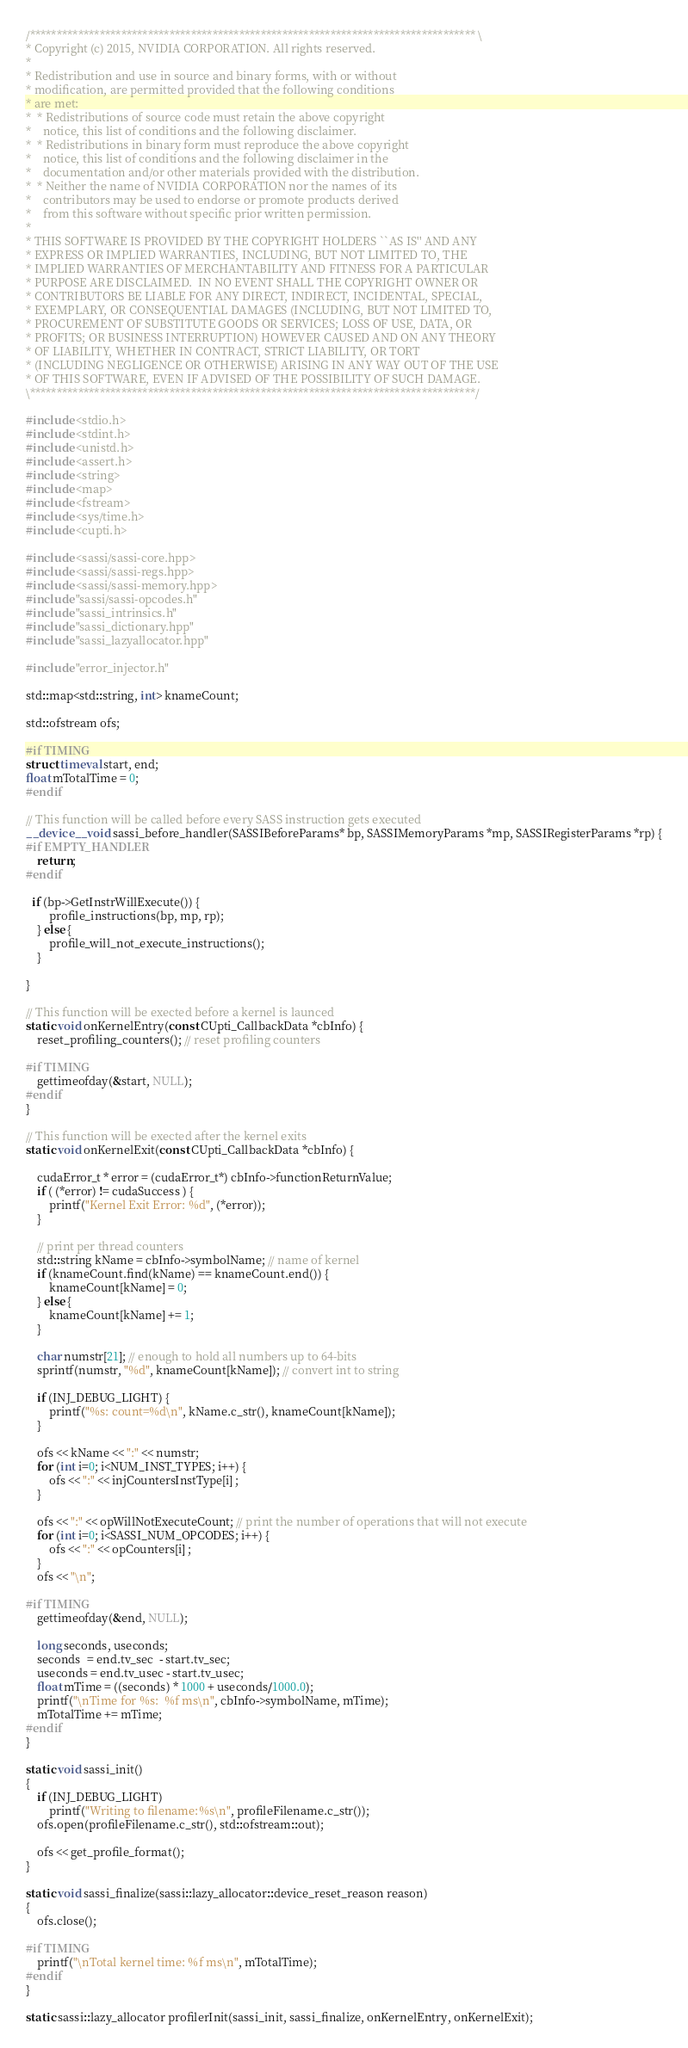<code> <loc_0><loc_0><loc_500><loc_500><_Cuda_>/*********************************************************************************** \
* Copyright (c) 2015, NVIDIA CORPORATION. All rights reserved.
*
* Redistribution and use in source and binary forms, with or without
* modification, are permitted provided that the following conditions
* are met:
*  * Redistributions of source code must retain the above copyright
*    notice, this list of conditions and the following disclaimer.
*  * Redistributions in binary form must reproduce the above copyright
*    notice, this list of conditions and the following disclaimer in the
*    documentation and/or other materials provided with the distribution.
*  * Neither the name of NVIDIA CORPORATION nor the names of its
*    contributors may be used to endorse or promote products derived
*    from this software without specific prior written permission.
*
* THIS SOFTWARE IS PROVIDED BY THE COPYRIGHT HOLDERS ``AS IS'' AND ANY
* EXPRESS OR IMPLIED WARRANTIES, INCLUDING, BUT NOT LIMITED TO, THE
* IMPLIED WARRANTIES OF MERCHANTABILITY AND FITNESS FOR A PARTICULAR
* PURPOSE ARE DISCLAIMED.  IN NO EVENT SHALL THE COPYRIGHT OWNER OR
* CONTRIBUTORS BE LIABLE FOR ANY DIRECT, INDIRECT, INCIDENTAL, SPECIAL,
* EXEMPLARY, OR CONSEQUENTIAL DAMAGES (INCLUDING, BUT NOT LIMITED TO,
* PROCUREMENT OF SUBSTITUTE GOODS OR SERVICES; LOSS OF USE, DATA, OR
* PROFITS; OR BUSINESS INTERRUPTION) HOWEVER CAUSED AND ON ANY THEORY
* OF LIABILITY, WHETHER IN CONTRACT, STRICT LIABILITY, OR TORT
* (INCLUDING NEGLIGENCE OR OTHERWISE) ARISING IN ANY WAY OUT OF THE USE
* OF THIS SOFTWARE, EVEN IF ADVISED OF THE POSSIBILITY OF SUCH DAMAGE.
\***********************************************************************************/

#include <stdio.h>
#include <stdint.h>
#include <unistd.h>
#include <assert.h>
#include <string>
#include <map>
#include <fstream>
#include <sys/time.h>
#include <cupti.h>

#include <sassi/sassi-core.hpp>
#include <sassi/sassi-regs.hpp>
#include <sassi/sassi-memory.hpp>
#include "sassi/sassi-opcodes.h"
#include "sassi_intrinsics.h"
#include "sassi_dictionary.hpp"
#include "sassi_lazyallocator.hpp"

#include "error_injector.h"

std::map<std::string, int> knameCount;

std::ofstream ofs; 

#if TIMING
struct timeval start, end;
float mTotalTime = 0;
#endif

// This function will be called before every SASS instruction gets executed 
__device__ void sassi_before_handler(SASSIBeforeParams* bp, SASSIMemoryParams *mp, SASSIRegisterParams *rp) {
#if EMPTY_HANDLER
	return;
#endif

  if (bp->GetInstrWillExecute()) {
		profile_instructions(bp, mp, rp);
	} else {
		profile_will_not_execute_instructions();
	}

}

// This function will be exected before a kernel is launced
static void onKernelEntry(const CUpti_CallbackData *cbInfo) {
	reset_profiling_counters(); // reset profiling counters

#if TIMING 
	gettimeofday(&start, NULL);
#endif
} 

// This function will be exected after the kernel exits 
static void onKernelExit(const CUpti_CallbackData *cbInfo) {

	cudaError_t * error = (cudaError_t*) cbInfo->functionReturnValue; 
	if ( (*error) != cudaSuccess ) {
		printf("Kernel Exit Error: %d", (*error));
	}

	// print per thread counters
	std::string kName = cbInfo->symbolName; // name of kernel
	if (knameCount.find(kName) == knameCount.end()) {
		knameCount[kName] = 0;
	} else {
		knameCount[kName] += 1;				
	}

	char numstr[21]; // enough to hold all numbers up to 64-bits
	sprintf(numstr, "%d", knameCount[kName]); // convert int to string

	if (INJ_DEBUG_LIGHT) {
		printf("%s: count=%d\n", kName.c_str(), knameCount[kName]);
	}

	ofs << kName << ":" << numstr;
	for (int i=0; i<NUM_INST_TYPES; i++) {
		ofs << ":" << injCountersInstType[i] ;
	}

	ofs << ":" << opWillNotExecuteCount; // print the number of operations that will not execute
	for (int i=0; i<SASSI_NUM_OPCODES; i++) {
		ofs << ":" << opCounters[i] ;
	}
	ofs << "\n";

#if TIMING
	gettimeofday(&end, NULL);

	long seconds, useconds;    
	seconds  = end.tv_sec  - start.tv_sec;
	useconds = end.tv_usec - start.tv_usec;
	float mTime = ((seconds) * 1000 + useconds/1000.0);
	printf("\nTime for %s:  %f ms\n", cbInfo->symbolName, mTime);
	mTotalTime += mTime;
#endif
} 

static void sassi_init() 
{
	if (INJ_DEBUG_LIGHT)
		printf("Writing to filename:%s\n", profileFilename.c_str());
	ofs.open(profileFilename.c_str(), std::ofstream::out);

	ofs << get_profile_format();
}

static void sassi_finalize(sassi::lazy_allocator::device_reset_reason reason)
{
	ofs.close();

#if TIMING
	printf("\nTotal kernel time: %f ms\n", mTotalTime);
#endif
}

static sassi::lazy_allocator profilerInit(sassi_init, sassi_finalize, onKernelEntry, onKernelExit); 
</code> 